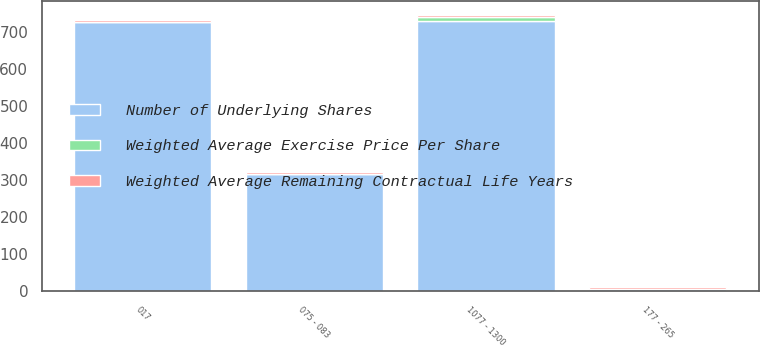Convert chart to OTSL. <chart><loc_0><loc_0><loc_500><loc_500><stacked_bar_chart><ecel><fcel>017<fcel>075 - 083<fcel>177 - 265<fcel>1077 - 1300<nl><fcel>Number of Underlying Shares<fcel>727<fcel>316<fcel>5.41<fcel>730<nl><fcel>Weighted Average Exercise Price Per Share<fcel>0.17<fcel>0.76<fcel>2.34<fcel>11.43<nl><fcel>Weighted Average Remaining Contractual Life Years<fcel>5.41<fcel>6.11<fcel>4.92<fcel>4.67<nl></chart> 